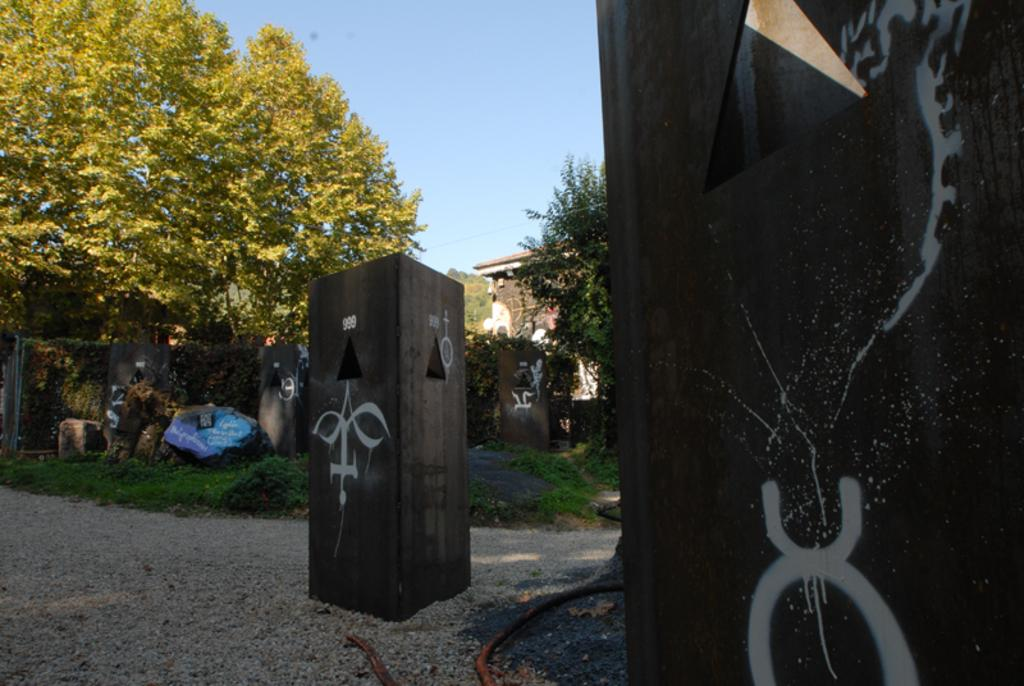What can be seen on the left side of the image? There is a tree on the grass land on the left side of the image. What objects are present on the right side and middle of the image? There are wooden boxes on the right side and middle of the image. What is located in the background of the image? There is a building with trees in front of it in the background of the image. What part of the natural environment is visible above the building? The sky is visible above the building. Can you tell me how many robins are perched on the tree in the image? There are no robins present in the image; it features a tree on the grass land. Who is the manager of the building in the background of the image? There is no information about a manager in the image, as it only shows a building with trees in front of it. 